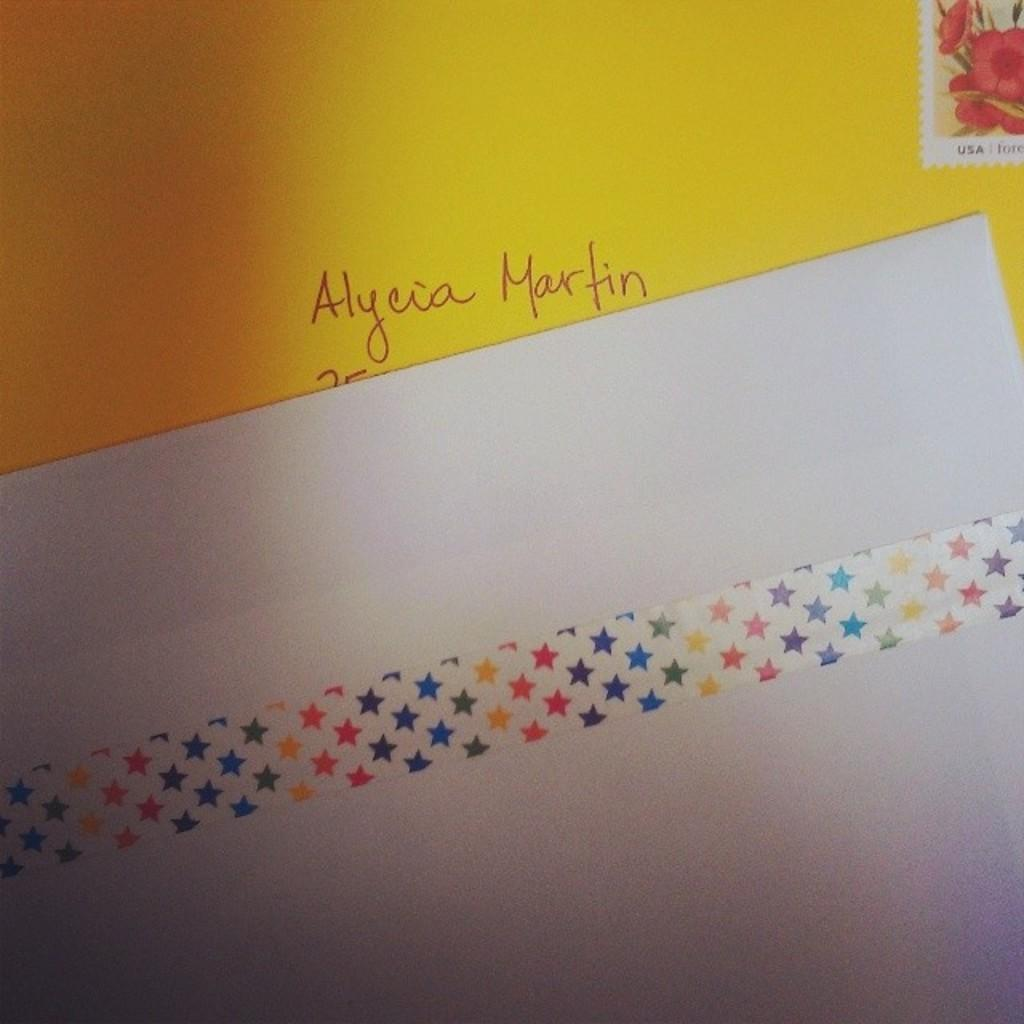<image>
Share a concise interpretation of the image provided. a yellow envelope addressed to alycia martin with a flower stamp on it 